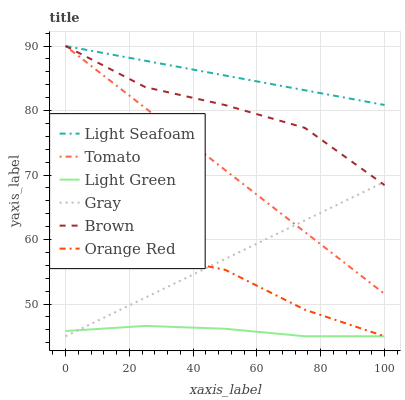Does Light Green have the minimum area under the curve?
Answer yes or no. Yes. Does Light Seafoam have the maximum area under the curve?
Answer yes or no. Yes. Does Gray have the minimum area under the curve?
Answer yes or no. No. Does Gray have the maximum area under the curve?
Answer yes or no. No. Is Light Seafoam the smoothest?
Answer yes or no. Yes. Is Brown the roughest?
Answer yes or no. Yes. Is Gray the smoothest?
Answer yes or no. No. Is Gray the roughest?
Answer yes or no. No. Does Brown have the lowest value?
Answer yes or no. No. Does Light Seafoam have the highest value?
Answer yes or no. Yes. Does Gray have the highest value?
Answer yes or no. No. Is Orange Red less than Brown?
Answer yes or no. Yes. Is Tomato greater than Orange Red?
Answer yes or no. Yes. Does Brown intersect Tomato?
Answer yes or no. Yes. Is Brown less than Tomato?
Answer yes or no. No. Is Brown greater than Tomato?
Answer yes or no. No. Does Orange Red intersect Brown?
Answer yes or no. No. 